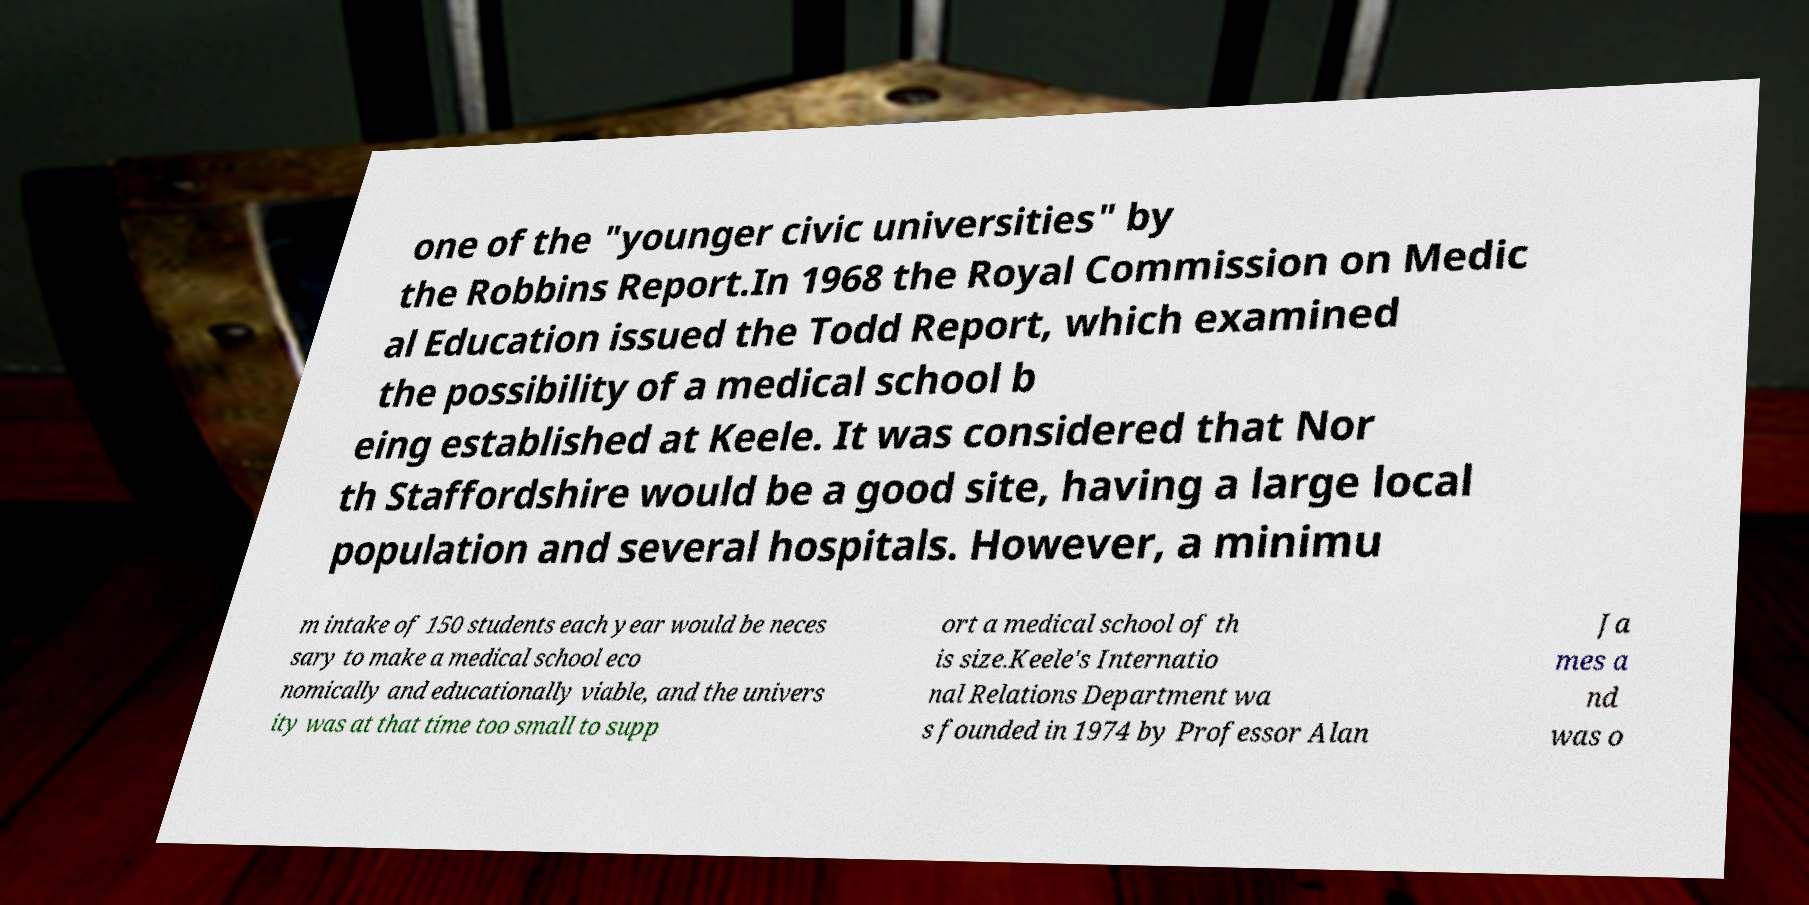For documentation purposes, I need the text within this image transcribed. Could you provide that? one of the "younger civic universities" by the Robbins Report.In 1968 the Royal Commission on Medic al Education issued the Todd Report, which examined the possibility of a medical school b eing established at Keele. It was considered that Nor th Staffordshire would be a good site, having a large local population and several hospitals. However, a minimu m intake of 150 students each year would be neces sary to make a medical school eco nomically and educationally viable, and the univers ity was at that time too small to supp ort a medical school of th is size.Keele's Internatio nal Relations Department wa s founded in 1974 by Professor Alan Ja mes a nd was o 